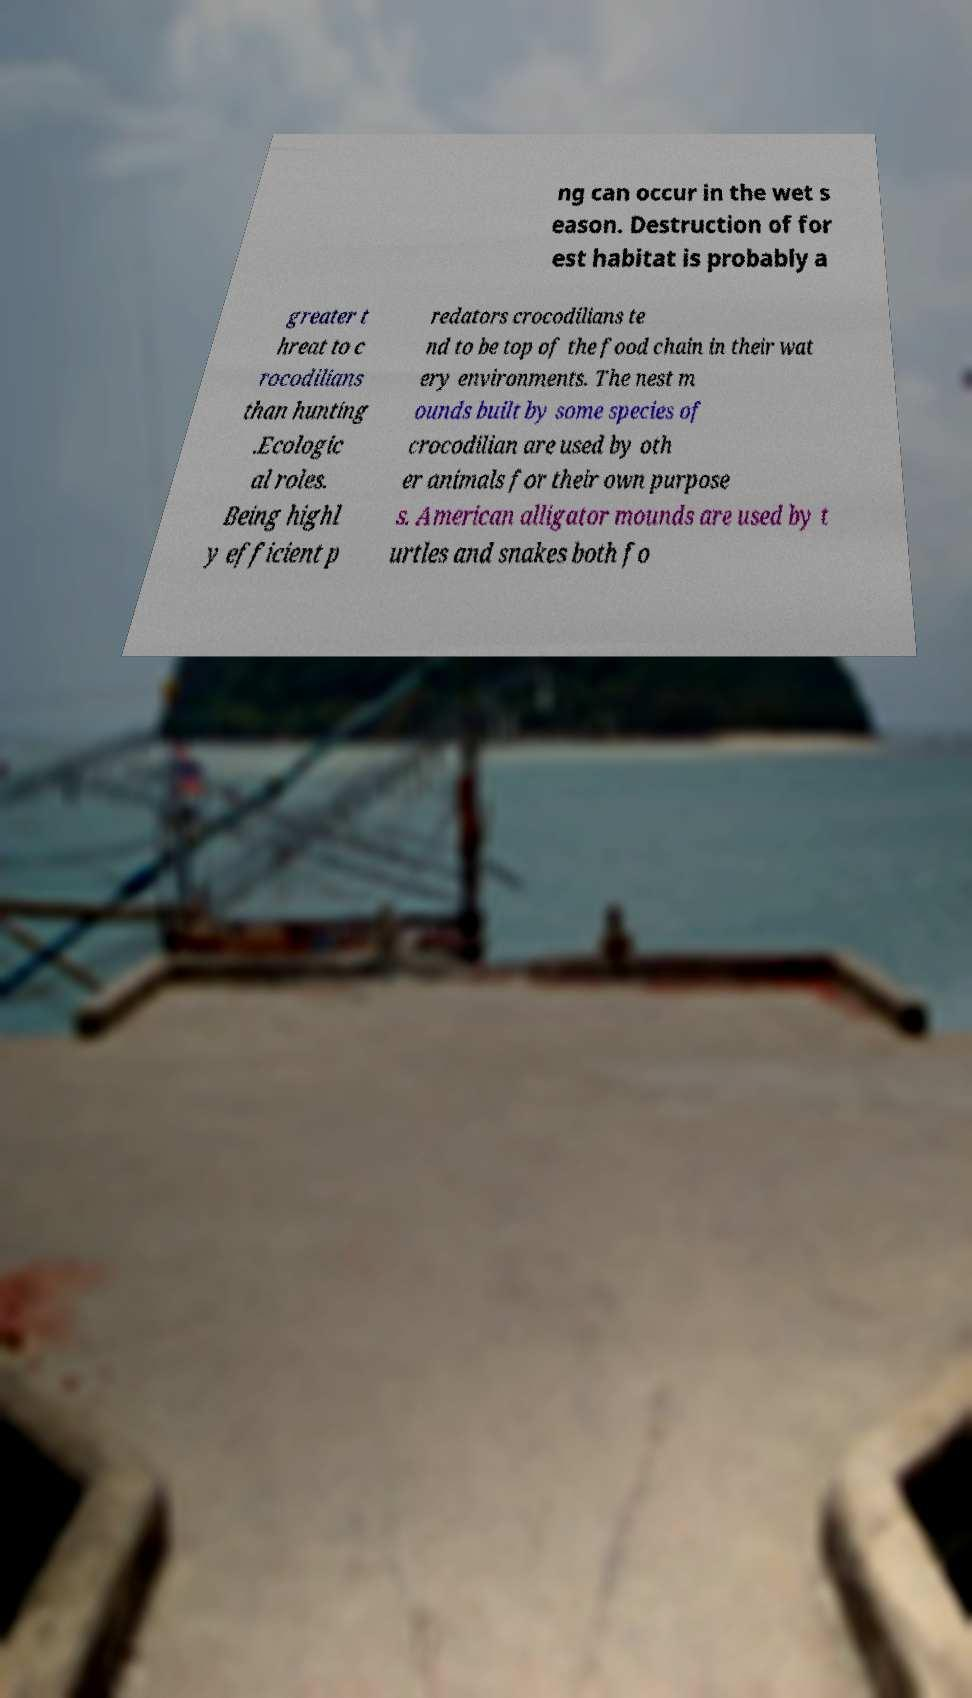Can you accurately transcribe the text from the provided image for me? ng can occur in the wet s eason. Destruction of for est habitat is probably a greater t hreat to c rocodilians than hunting .Ecologic al roles. Being highl y efficient p redators crocodilians te nd to be top of the food chain in their wat ery environments. The nest m ounds built by some species of crocodilian are used by oth er animals for their own purpose s. American alligator mounds are used by t urtles and snakes both fo 